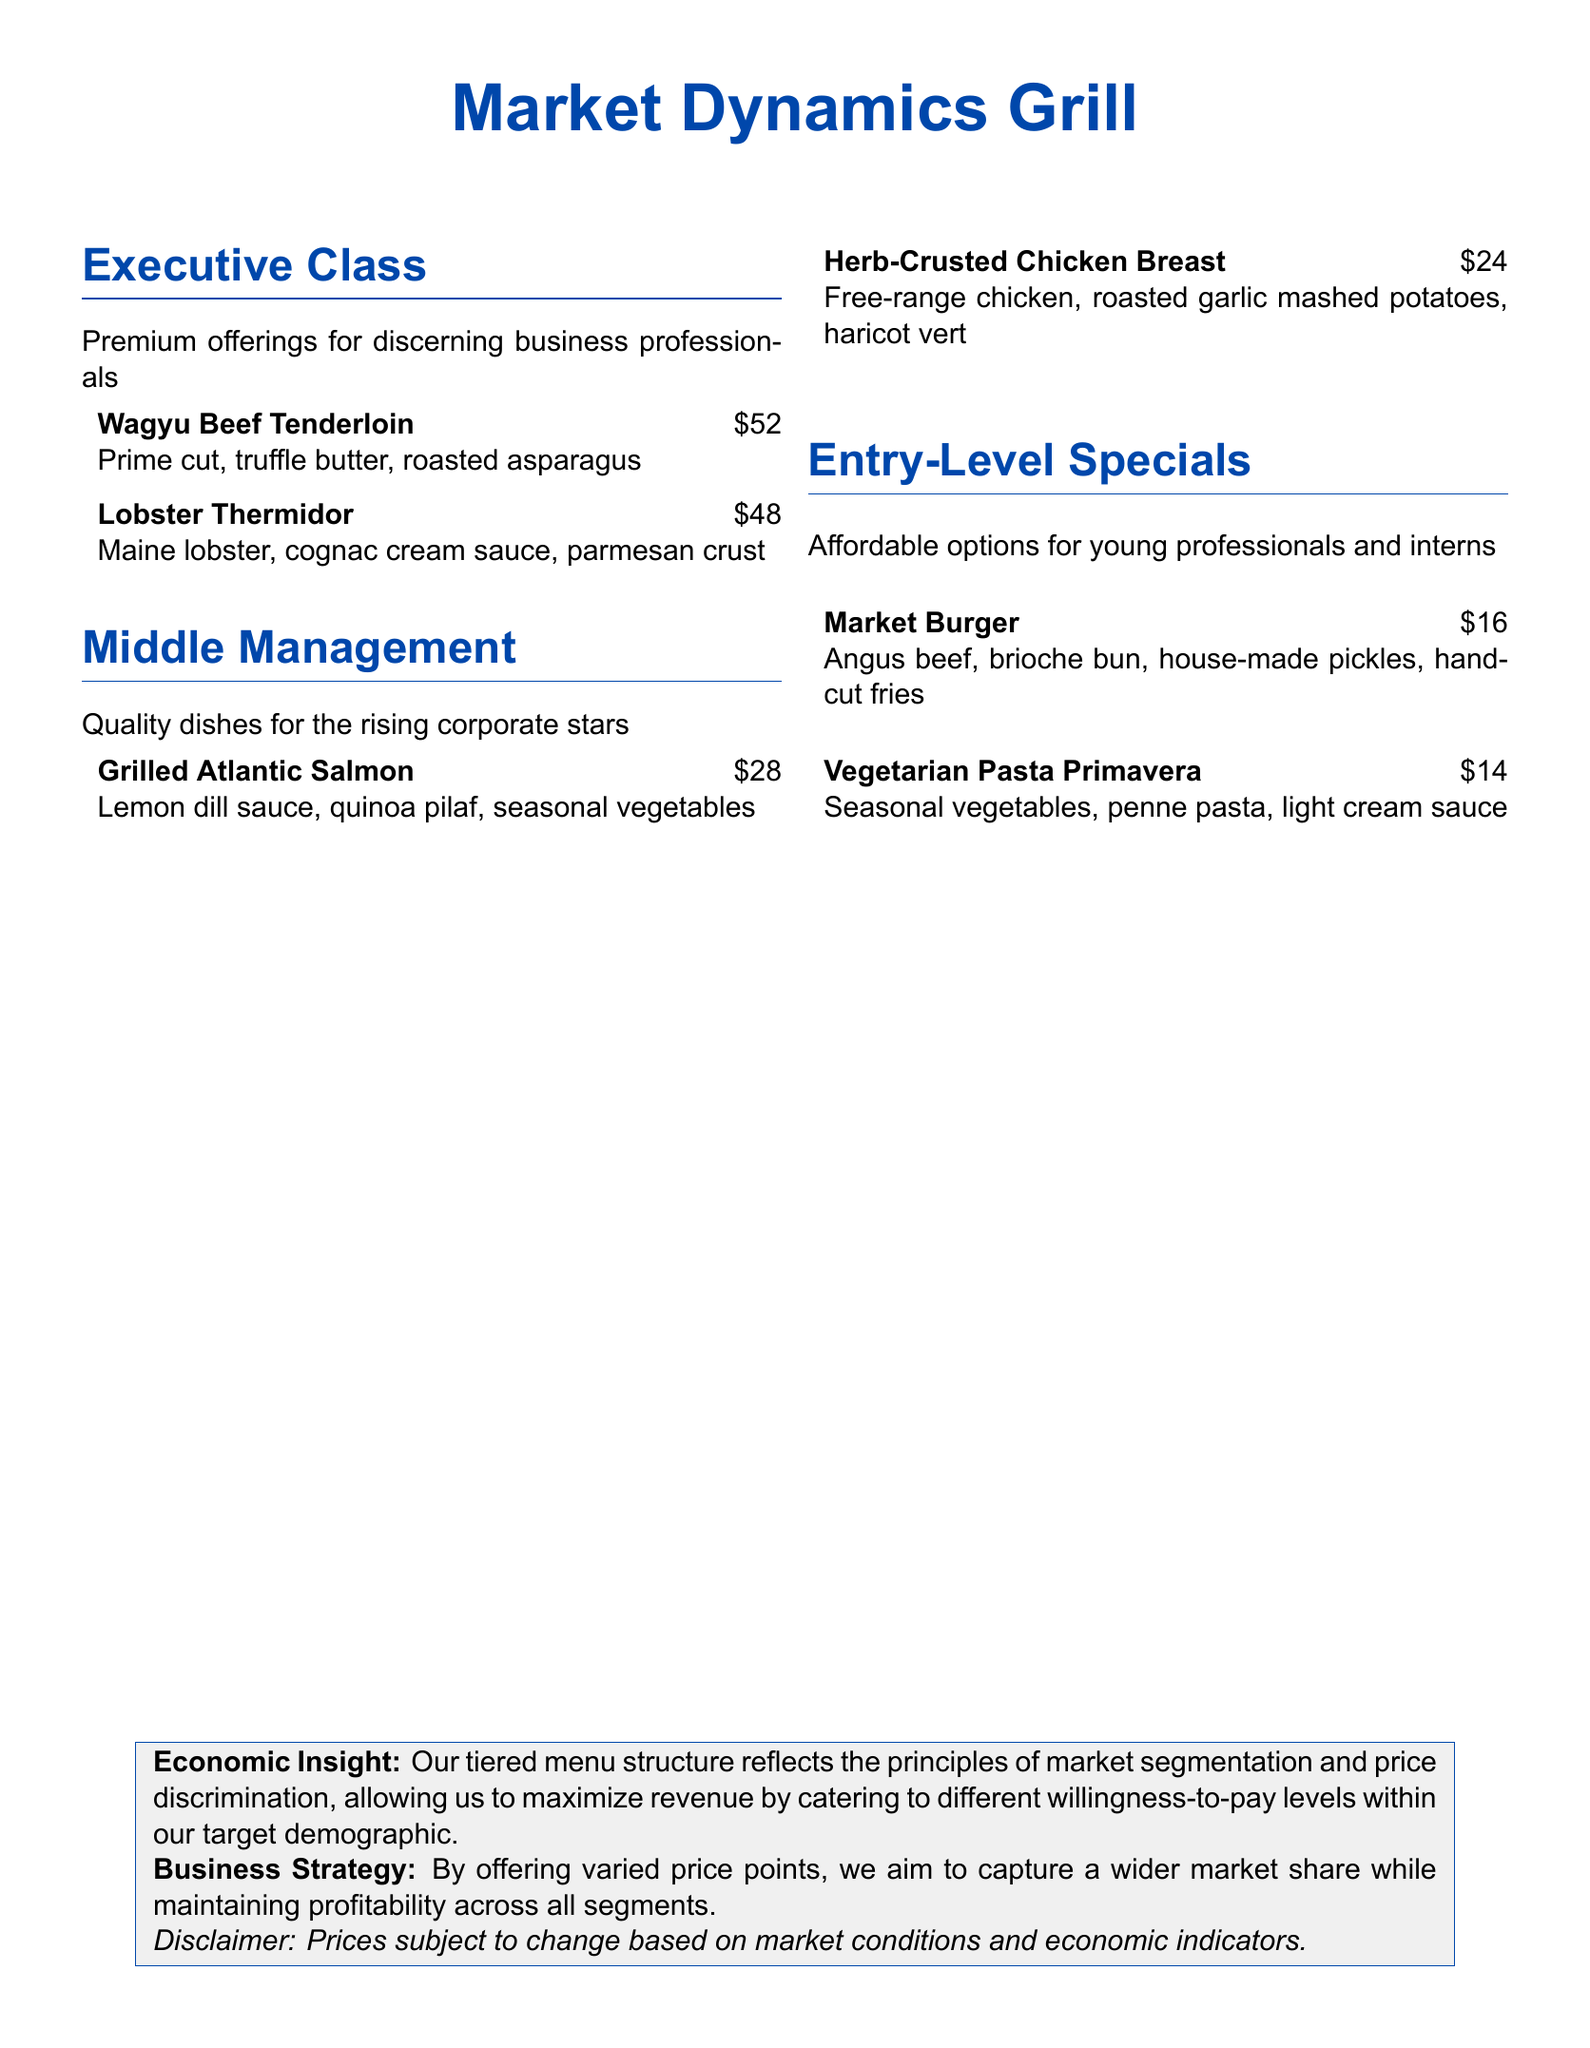What is the name of the restaurant? The name of the restaurant is prominently displayed at the top of the document.
Answer: Market Dynamics Grill How many sections are there on the menu? The document lists three distinct sections for different customer tiers.
Answer: 3 What is the price of the Wagyu Beef Tenderloin? The menu item price is indicated next to the name of the dish.
Answer: $52 Which dish is offered at the lowest price point? The document shows the prices for all dishes, and the lowest price is highlighted in the Entry-Level Specials section.
Answer: Market Burger What is the primary target demographic of the Executive Class section? The description under each section clarifies who the dishes are catering to.
Answer: Discerning business professionals What strategic principle is reflected in the tiered menu structure? This is explained in the Economic Insight section as a method for revenue maximization.
Answer: Market segmentation How much is the Lobster Thermidor? The price is mentioned next to the name of the item on the menu.
Answer: $48 What does the disclaimer at the bottom mention? The disclaimer provides important notes regarding pricing that is subject to change.
Answer: Prices subject to change based on market conditions What type of sauce accompanies the Grilled Atlantic Salmon? The accompanying details of menu items include the specific sauce used with the dish.
Answer: Lemon dill sauce Which dish is classified under Middle Management? The menu specifies the dishes that fit within the Middle Management tier.
Answer: Grilled Atlantic Salmon 